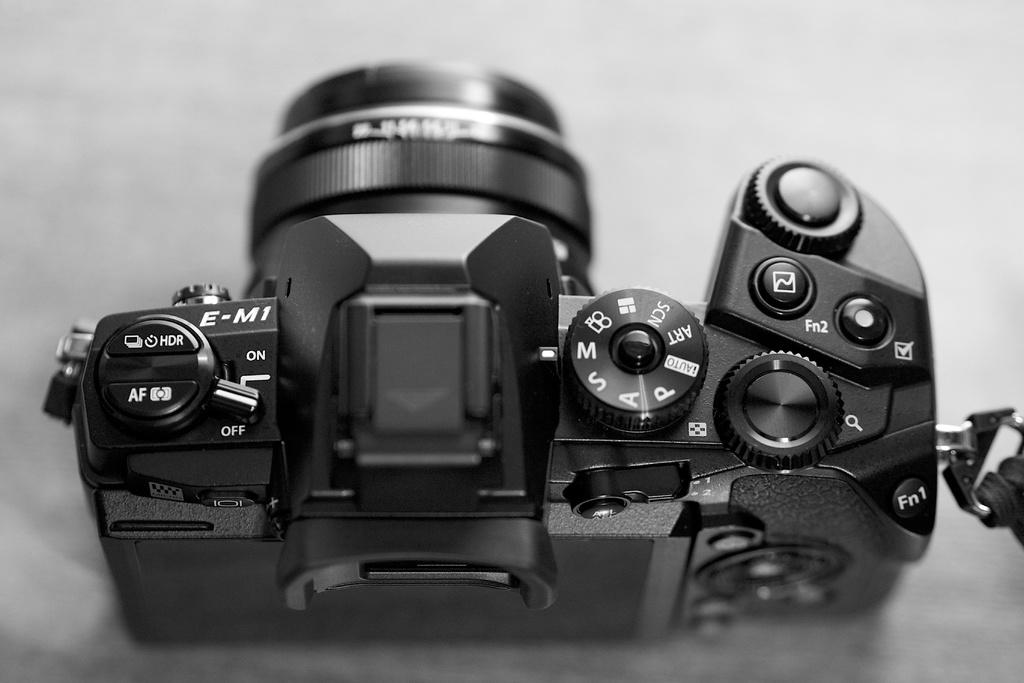What is the main object in the image? There is a camera in the image. Where is the camera located? The camera is on a table. What type of advertisement is displayed on the camera in the image? There is no advertisement displayed on the camera in the image. What color is the grain in the image? There is no grain present in the image. 